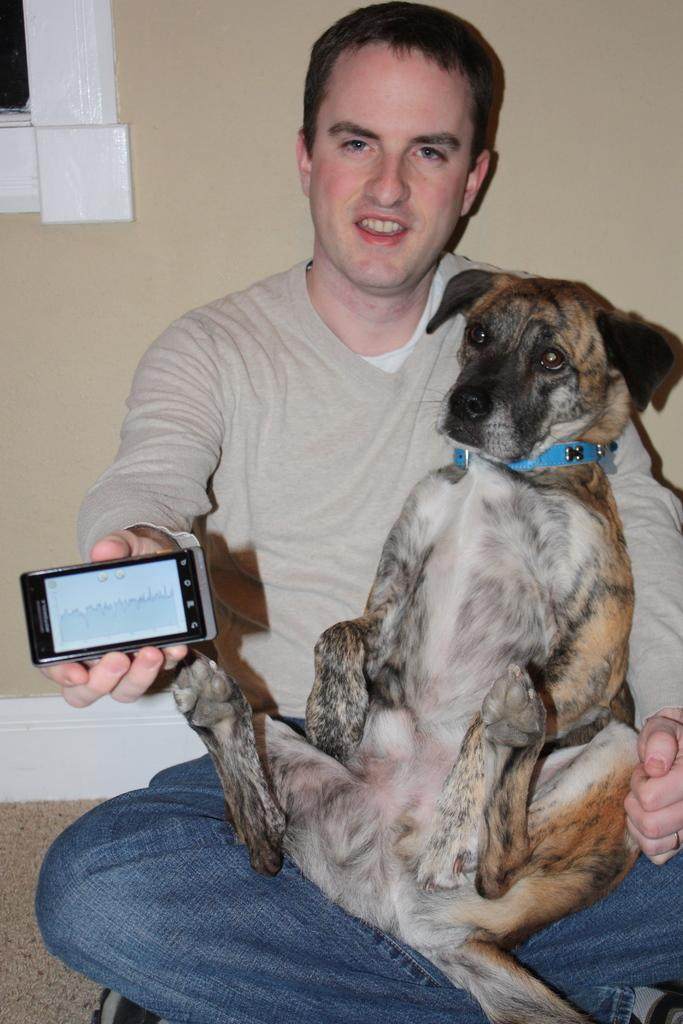What is the man in the image doing? The man is sitting in the middle of the image. What is the man's facial expression in the image? The man is smiling. What is the man holding in the image? The man is holding a dog and a mobile phone. What is visible behind the man in the image? There is a wall behind the man. What type of paper can be seen in the image? There is no paper present in the image. What vegetables are being used as a prop in the image? There are no vegetables present in the image. 